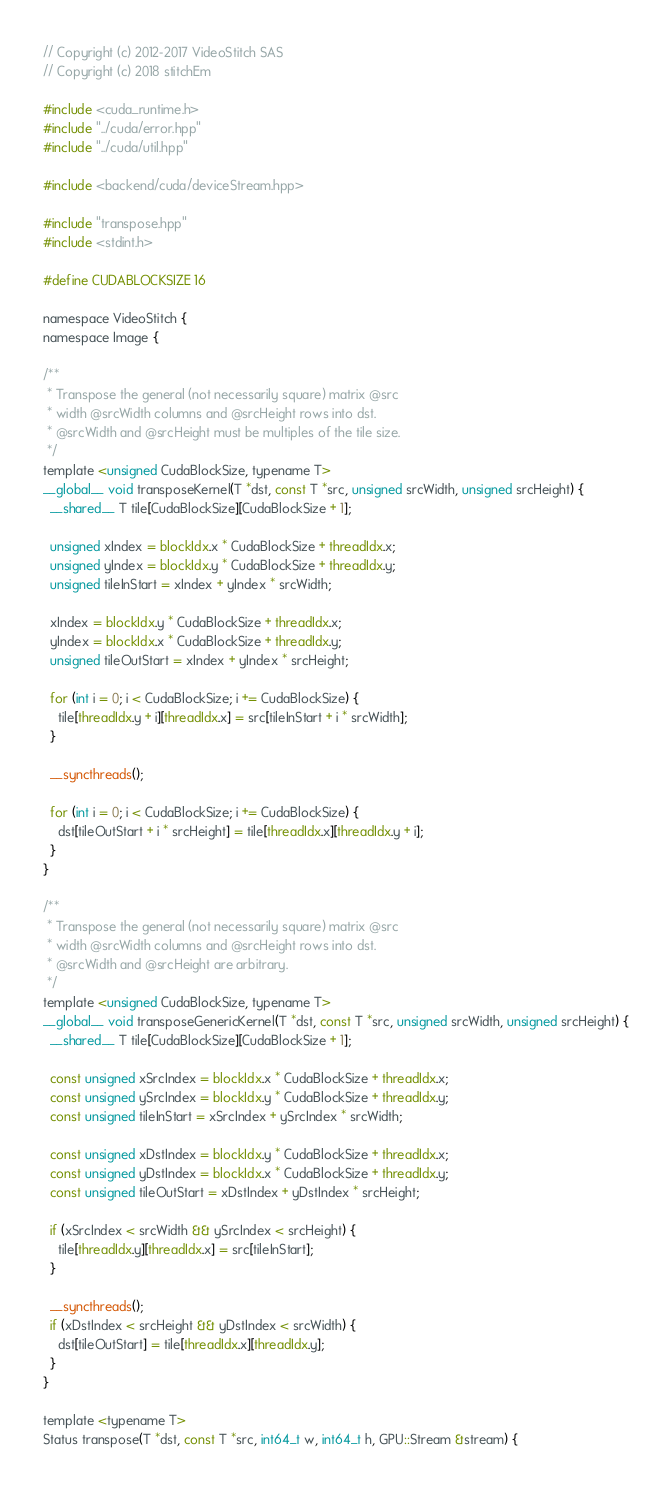<code> <loc_0><loc_0><loc_500><loc_500><_Cuda_>// Copyright (c) 2012-2017 VideoStitch SAS
// Copyright (c) 2018 stitchEm

#include <cuda_runtime.h>
#include "../cuda/error.hpp"
#include "../cuda/util.hpp"

#include <backend/cuda/deviceStream.hpp>

#include "transpose.hpp"
#include <stdint.h>

#define CUDABLOCKSIZE 16

namespace VideoStitch {
namespace Image {

/**
 * Transpose the general (not necessarily square) matrix @src
 * width @srcWidth columns and @srcHeight rows into dst.
 * @srcWidth and @srcHeight must be multiples of the tile size.
 */
template <unsigned CudaBlockSize, typename T>
__global__ void transposeKernel(T *dst, const T *src, unsigned srcWidth, unsigned srcHeight) {
  __shared__ T tile[CudaBlockSize][CudaBlockSize + 1];

  unsigned xIndex = blockIdx.x * CudaBlockSize + threadIdx.x;
  unsigned yIndex = blockIdx.y * CudaBlockSize + threadIdx.y;
  unsigned tileInStart = xIndex + yIndex * srcWidth;

  xIndex = blockIdx.y * CudaBlockSize + threadIdx.x;
  yIndex = blockIdx.x * CudaBlockSize + threadIdx.y;
  unsigned tileOutStart = xIndex + yIndex * srcHeight;

  for (int i = 0; i < CudaBlockSize; i += CudaBlockSize) {
    tile[threadIdx.y + i][threadIdx.x] = src[tileInStart + i * srcWidth];
  }

  __syncthreads();

  for (int i = 0; i < CudaBlockSize; i += CudaBlockSize) {
    dst[tileOutStart + i * srcHeight] = tile[threadIdx.x][threadIdx.y + i];
  }
}

/**
 * Transpose the general (not necessarily square) matrix @src
 * width @srcWidth columns and @srcHeight rows into dst.
 * @srcWidth and @srcHeight are arbitrary.
 */
template <unsigned CudaBlockSize, typename T>
__global__ void transposeGenericKernel(T *dst, const T *src, unsigned srcWidth, unsigned srcHeight) {
  __shared__ T tile[CudaBlockSize][CudaBlockSize + 1];

  const unsigned xSrcIndex = blockIdx.x * CudaBlockSize + threadIdx.x;
  const unsigned ySrcIndex = blockIdx.y * CudaBlockSize + threadIdx.y;
  const unsigned tileInStart = xSrcIndex + ySrcIndex * srcWidth;

  const unsigned xDstIndex = blockIdx.y * CudaBlockSize + threadIdx.x;
  const unsigned yDstIndex = blockIdx.x * CudaBlockSize + threadIdx.y;
  const unsigned tileOutStart = xDstIndex + yDstIndex * srcHeight;

  if (xSrcIndex < srcWidth && ySrcIndex < srcHeight) {
    tile[threadIdx.y][threadIdx.x] = src[tileInStart];
  }

  __syncthreads();
  if (xDstIndex < srcHeight && yDstIndex < srcWidth) {
    dst[tileOutStart] = tile[threadIdx.x][threadIdx.y];
  }
}

template <typename T>
Status transpose(T *dst, const T *src, int64_t w, int64_t h, GPU::Stream &stream) {</code> 